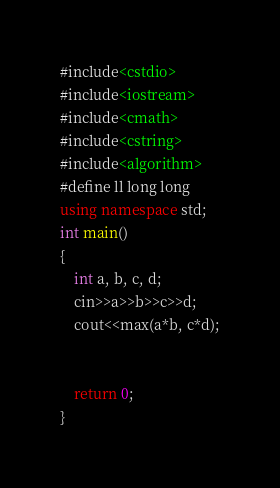Convert code to text. <code><loc_0><loc_0><loc_500><loc_500><_C++_>#include<cstdio>
#include<iostream>
#include<cmath>
#include<cstring>
#include<algorithm>
#define ll long long
using namespace std;
int main()
{
    int a, b, c, d;
    cin>>a>>b>>c>>d;
    cout<<max(a*b, c*d);


    return 0;
}
</code> 